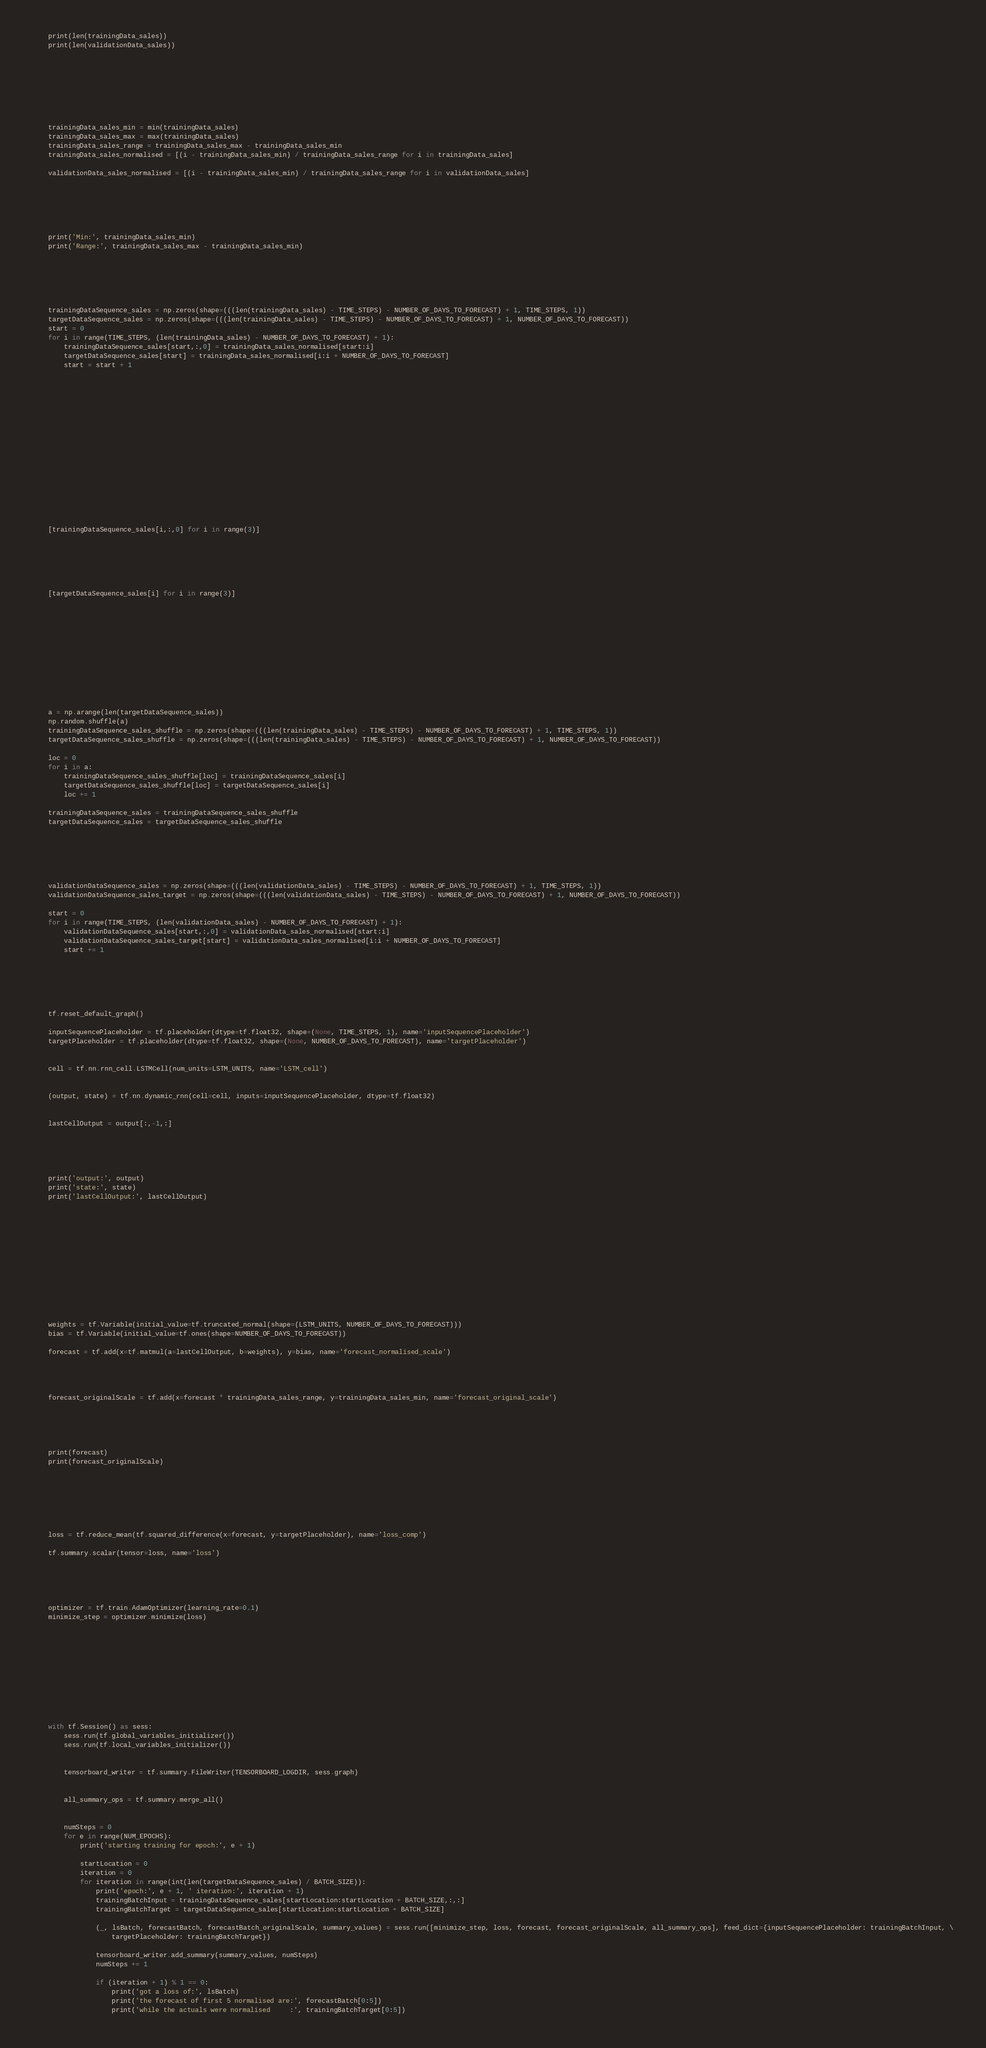<code> <loc_0><loc_0><loc_500><loc_500><_Python_>    print(len(trainingData_sales))
    print(len(validationData_sales))
    
    
    
    
    
    
    
    
    trainingData_sales_min = min(trainingData_sales)
    trainingData_sales_max = max(trainingData_sales)
    trainingData_sales_range = trainingData_sales_max - trainingData_sales_min
    trainingData_sales_normalised = [(i - trainingData_sales_min) / trainingData_sales_range for i in trainingData_sales]
    
    validationData_sales_normalised = [(i - trainingData_sales_min) / trainingData_sales_range for i in validationData_sales]
    
    
    
    
    
    
    print('Min:', trainingData_sales_min)
    print('Range:', trainingData_sales_max - trainingData_sales_min)
    
    
    
    
    
    
    trainingDataSequence_sales = np.zeros(shape=(((len(trainingData_sales) - TIME_STEPS) - NUMBER_OF_DAYS_TO_FORECAST) + 1, TIME_STEPS, 1))
    targetDataSequence_sales = np.zeros(shape=(((len(trainingData_sales) - TIME_STEPS) - NUMBER_OF_DAYS_TO_FORECAST) + 1, NUMBER_OF_DAYS_TO_FORECAST))
    start = 0
    for i in range(TIME_STEPS, (len(trainingData_sales) - NUMBER_OF_DAYS_TO_FORECAST) + 1):
        trainingDataSequence_sales[start,:,0] = trainingData_sales_normalised[start:i]
        targetDataSequence_sales[start] = trainingData_sales_normalised[i:i + NUMBER_OF_DAYS_TO_FORECAST]
        start = start + 1
    
    
    
    
    
    
    
    
    
    
    
    
    
    
    
    
    
    [trainingDataSequence_sales[i,:,0] for i in range(3)]
    
    
    
    
    
    
    [targetDataSequence_sales[i] for i in range(3)]
    
    
    
    
    
    
    
    
    
    
    
    
    a = np.arange(len(targetDataSequence_sales))
    np.random.shuffle(a)
    trainingDataSequence_sales_shuffle = np.zeros(shape=(((len(trainingData_sales) - TIME_STEPS) - NUMBER_OF_DAYS_TO_FORECAST) + 1, TIME_STEPS, 1))
    targetDataSequence_sales_shuffle = np.zeros(shape=(((len(trainingData_sales) - TIME_STEPS) - NUMBER_OF_DAYS_TO_FORECAST) + 1, NUMBER_OF_DAYS_TO_FORECAST))
    
    loc = 0
    for i in a:
        trainingDataSequence_sales_shuffle[loc] = trainingDataSequence_sales[i]
        targetDataSequence_sales_shuffle[loc] = targetDataSequence_sales[i]
        loc += 1
    
    trainingDataSequence_sales = trainingDataSequence_sales_shuffle
    targetDataSequence_sales = targetDataSequence_sales_shuffle
    
    
    
    
    
    
    validationDataSequence_sales = np.zeros(shape=(((len(validationData_sales) - TIME_STEPS) - NUMBER_OF_DAYS_TO_FORECAST) + 1, TIME_STEPS, 1))
    validationDataSequence_sales_target = np.zeros(shape=(((len(validationData_sales) - TIME_STEPS) - NUMBER_OF_DAYS_TO_FORECAST) + 1, NUMBER_OF_DAYS_TO_FORECAST))
    
    start = 0
    for i in range(TIME_STEPS, (len(validationData_sales) - NUMBER_OF_DAYS_TO_FORECAST) + 1):
        validationDataSequence_sales[start,:,0] = validationData_sales_normalised[start:i]
        validationDataSequence_sales_target[start] = validationData_sales_normalised[i:i + NUMBER_OF_DAYS_TO_FORECAST]
        start += 1
    
    
    
    
    
    
    tf.reset_default_graph()
    
    inputSequencePlaceholder = tf.placeholder(dtype=tf.float32, shape=(None, TIME_STEPS, 1), name='inputSequencePlaceholder')
    targetPlaceholder = tf.placeholder(dtype=tf.float32, shape=(None, NUMBER_OF_DAYS_TO_FORECAST), name='targetPlaceholder')
    
    
    cell = tf.nn.rnn_cell.LSTMCell(num_units=LSTM_UNITS, name='LSTM_cell')
    
    
    (output, state) = tf.nn.dynamic_rnn(cell=cell, inputs=inputSequencePlaceholder, dtype=tf.float32)
    
    
    lastCellOutput = output[:,-1,:]
    
    
    
    
    
    print('output:', output)
    print('state:', state)
    print('lastCellOutput:', lastCellOutput)
    
    
    
    
    
    
    
    
    
    
    
    
    
    weights = tf.Variable(initial_value=tf.truncated_normal(shape=(LSTM_UNITS, NUMBER_OF_DAYS_TO_FORECAST)))
    bias = tf.Variable(initial_value=tf.ones(shape=NUMBER_OF_DAYS_TO_FORECAST))
    
    forecast = tf.add(x=tf.matmul(a=lastCellOutput, b=weights), y=bias, name='forecast_normalised_scale')
    
    
    
    
    forecast_originalScale = tf.add(x=forecast * trainingData_sales_range, y=trainingData_sales_min, name='forecast_original_scale')
    
    
    
    
    
    print(forecast)
    print(forecast_originalScale)
    
    
    
    
    
    
    
    loss = tf.reduce_mean(tf.squared_difference(x=forecast, y=targetPlaceholder), name='loss_comp')
    
    tf.summary.scalar(tensor=loss, name='loss')
    
    
    
    
    
    optimizer = tf.train.AdamOptimizer(learning_rate=0.1)
    minimize_step = optimizer.minimize(loss)
    
    
    
    
    
    
    
    
    
    
    
    with tf.Session() as sess:
        sess.run(tf.global_variables_initializer())
        sess.run(tf.local_variables_initializer())
        
        
        tensorboard_writer = tf.summary.FileWriter(TENSORBOARD_LOGDIR, sess.graph)
        
        
        all_summary_ops = tf.summary.merge_all()
        
        
        numSteps = 0
        for e in range(NUM_EPOCHS):
            print('starting training for epoch:', e + 1)
            
            startLocation = 0
            iteration = 0
            for iteration in range(int(len(targetDataSequence_sales) / BATCH_SIZE)):
                print('epoch:', e + 1, ' iteration:', iteration + 1)
                trainingBatchInput = trainingDataSequence_sales[startLocation:startLocation + BATCH_SIZE,:,:]
                trainingBatchTarget = targetDataSequence_sales[startLocation:startLocation + BATCH_SIZE]
                
                (_, lsBatch, forecastBatch, forecastBatch_originalScale, summary_values) = sess.run([minimize_step, loss, forecast, forecast_originalScale, all_summary_ops], feed_dict={inputSequencePlaceholder: trainingBatchInput, \
                    targetPlaceholder: trainingBatchTarget})
                
                tensorboard_writer.add_summary(summary_values, numSteps)
                numSteps += 1
                
                if (iteration + 1) % 1 == 0:
                    print('got a loss of:', lsBatch)
                    print('the forecast of first 5 normalised are:', forecastBatch[0:5])
                    print('while the actuals were normalised     :', trainingBatchTarget[0:5])</code> 